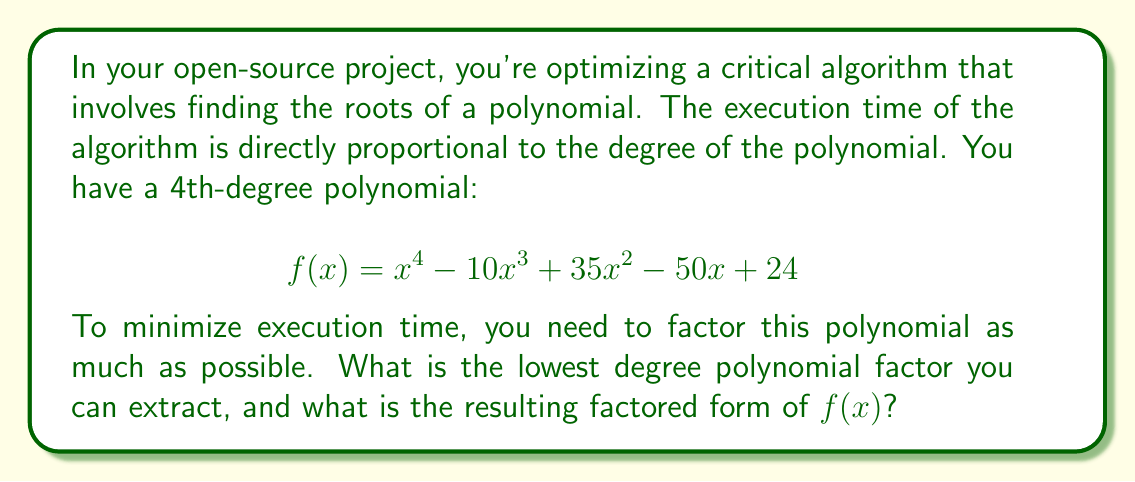Solve this math problem. Let's approach this step-by-step:

1) First, we should check for any rational roots using the rational root theorem. The possible rational roots are the factors of the constant term (24): ±1, ±2, ±3, ±4, ±6, ±8, ±12, ±24.

2) Testing these values, we find that x = 1 and x = 4 are roots of the polynomial.

3) We can factor out (x - 1) and (x - 4):

   $$ f(x) = (x - 1)(x - 4)(ax^2 + bx + c) $$

4) To find a, b, and c, we can expand this expression and compare coefficients with the original polynomial:

   $$ (x - 1)(x - 4)(ax^2 + bx + c) = ax^4 + (b-5a)x^3 + (c-4b+6a)x^2 + (-4c+b)x + 4c $$

5) Comparing coefficients:
   $a = 1$
   $b - 5a = -10$, so $b = -5$
   $c - 4b + 6a = 35$, so $c = 10$

6) Therefore, the factored form is:

   $$ f(x) = (x - 1)(x - 4)(x^2 - 5x + 10) $$

7) The quadratic factor $x^2 - 5x + 10$ cannot be factored further over the real numbers, as its discriminant is negative: $b^2 - 4ac = (-5)^2 - 4(1)(10) = 25 - 40 = -15 < 0$

Thus, the lowest degree polynomial factor we can extract is of degree 1, and this is the most reduced factored form of $f(x)$.
Answer: Degree 1; $f(x) = (x - 1)(x - 4)(x^2 - 5x + 10)$ 